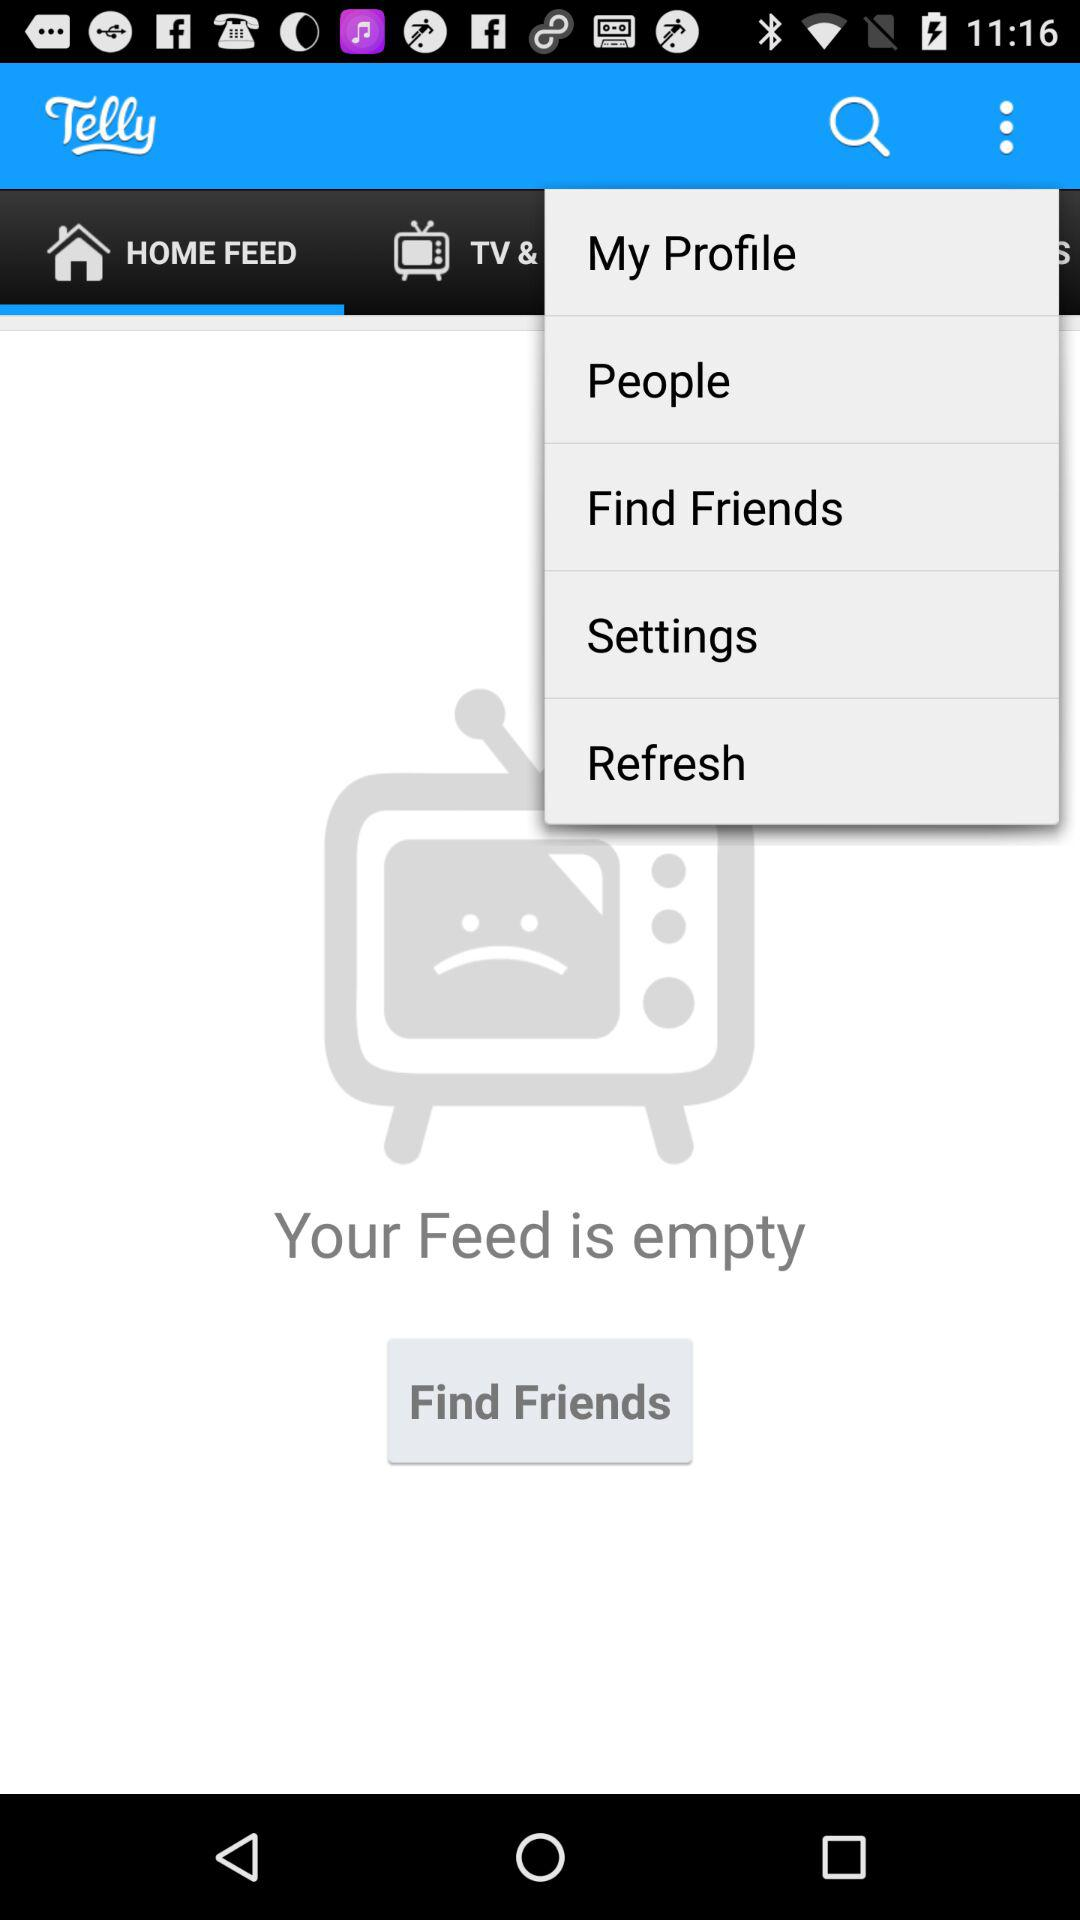Which tab is selected? The selected tab is "HOME FEED". 